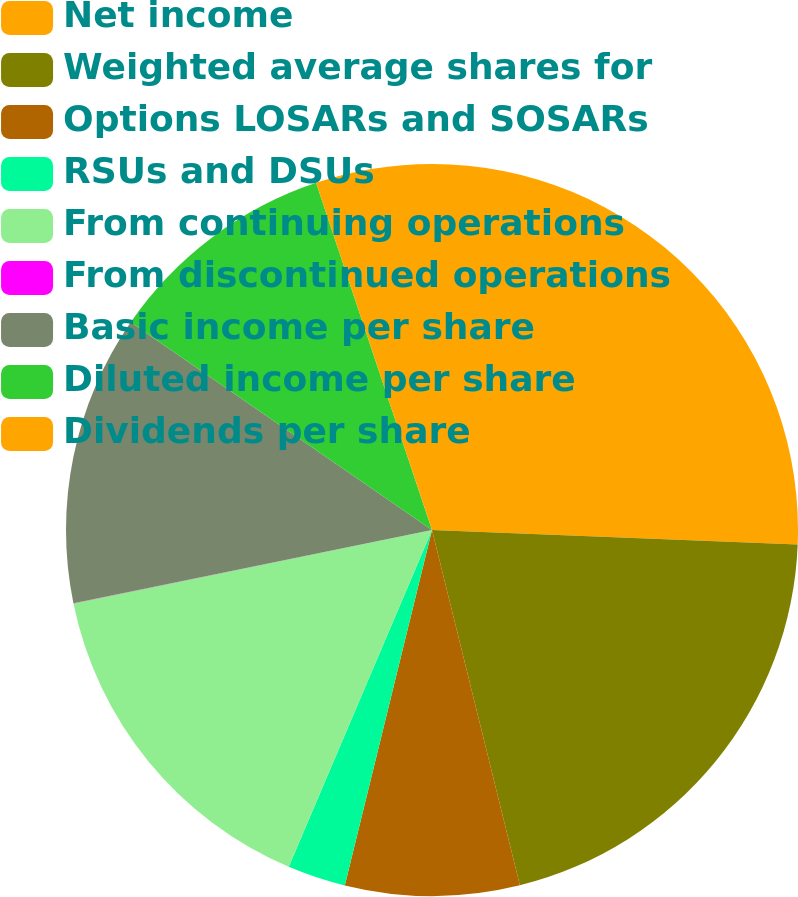Convert chart. <chart><loc_0><loc_0><loc_500><loc_500><pie_chart><fcel>Net income<fcel>Weighted average shares for<fcel>Options LOSARs and SOSARs<fcel>RSUs and DSUs<fcel>From continuing operations<fcel>From discontinued operations<fcel>Basic income per share<fcel>Diluted income per share<fcel>Dividends per share<nl><fcel>25.63%<fcel>20.51%<fcel>7.69%<fcel>2.57%<fcel>15.38%<fcel>0.01%<fcel>12.82%<fcel>10.26%<fcel>5.13%<nl></chart> 